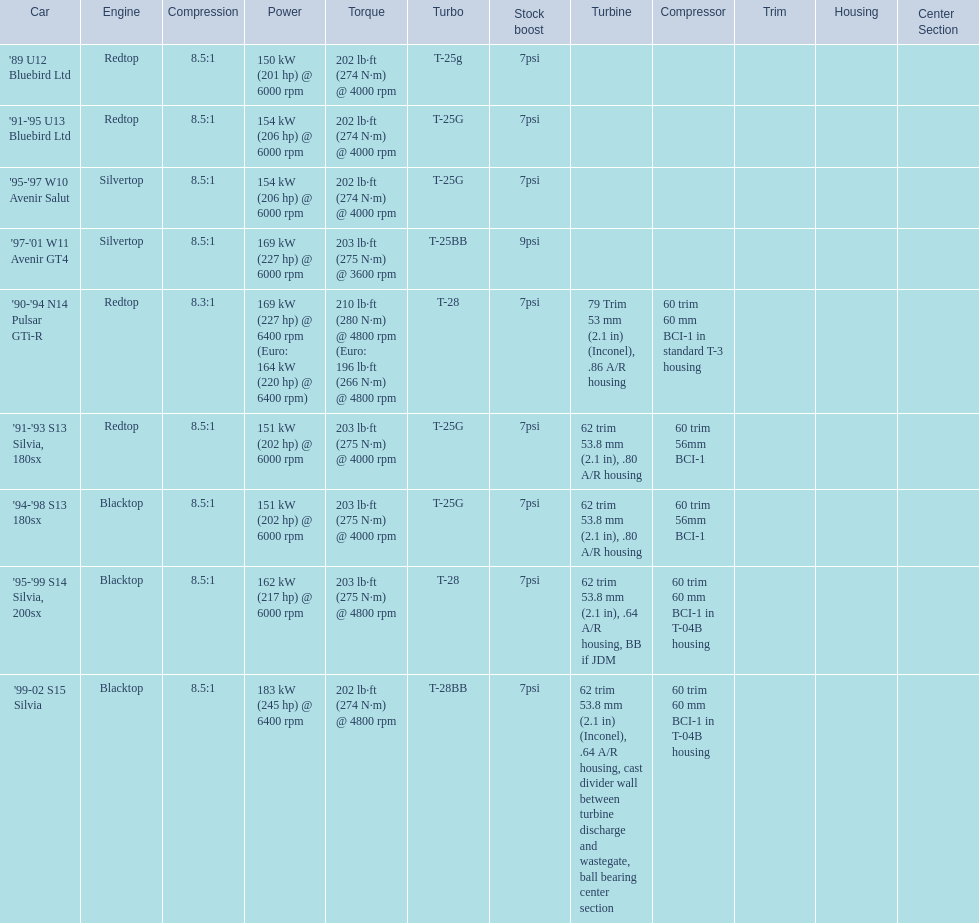Which engines are the same as the first entry ('89 u12 bluebird ltd)? '91-'95 U13 Bluebird Ltd, '90-'94 N14 Pulsar GTi-R, '91-'93 S13 Silvia, 180sx. 